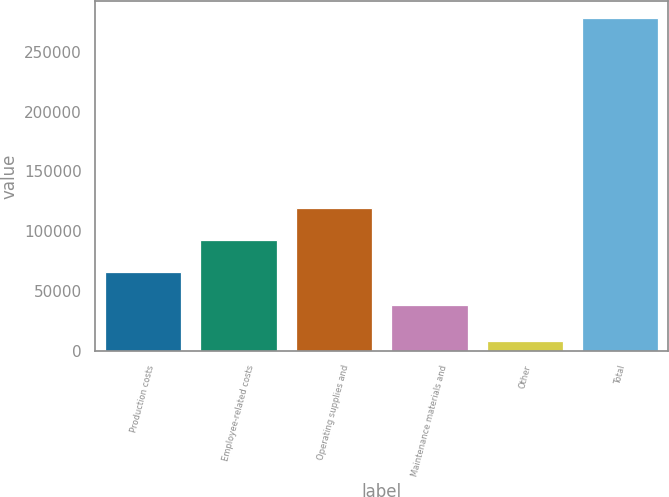Convert chart. <chart><loc_0><loc_0><loc_500><loc_500><bar_chart><fcel>Production costs<fcel>Employee-related costs<fcel>Operating supplies and<fcel>Maintenance materials and<fcel>Other<fcel>Total<nl><fcel>65570.9<fcel>92573.8<fcel>119577<fcel>38568<fcel>8346<fcel>278375<nl></chart> 